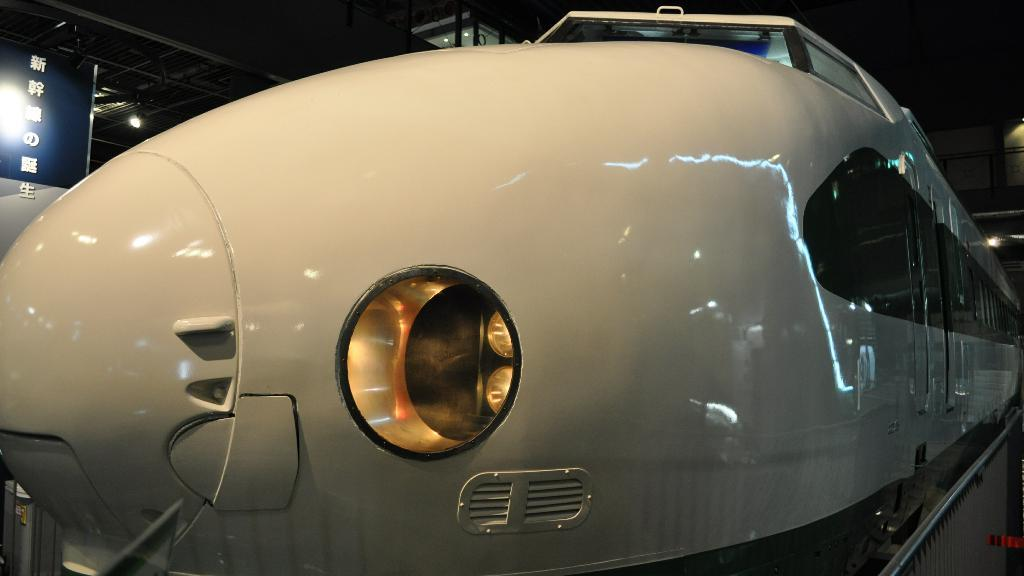What is the main subject of the image? The main subject of the image is a train. What feature can be seen at the front of the train? The train has lights at the front. What is located in the bottom right corner of the image? There is a fence in the bottom right corner of the image. What can be seen in the background of the image? There is a hoarding and poles in the background of the image, as well as lights. What type of vase is placed on the train in the image? There is no vase present on the train in the image. What emotion does the train appear to be experiencing in the image? Trains do not have emotions, so this question cannot be answered. 